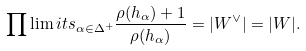<formula> <loc_0><loc_0><loc_500><loc_500>\prod \lim i t s _ { \alpha \in \Delta ^ { + } } \frac { \rho ( h _ { \alpha } ) + 1 } { \rho ( h _ { \alpha } ) } = | W ^ { \vee } | = | W | .</formula> 